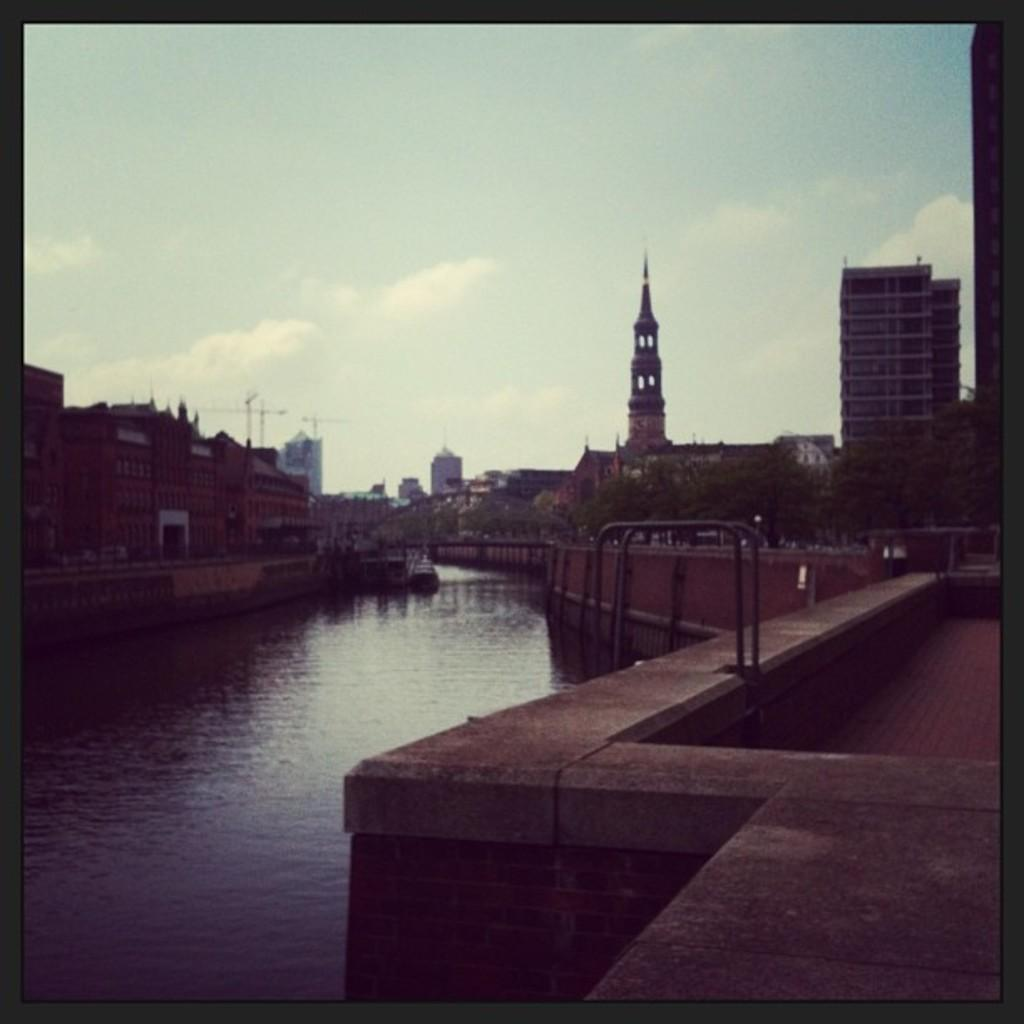What is the main feature of the image? The main feature of the image is water. What can be seen on either side of the water? There are buildings on either side of the water. What type of vegetation is present in the image? There are trees in the right corner of the image. What structure can be seen in the background? There is a bridge in the background of the image. What reward does the sister receive for crossing the bridge in the image? There is no sister present in the image, nor is there any indication of a reward or crossing a bridge. 